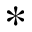<formula> <loc_0><loc_0><loc_500><loc_500>\ast</formula> 